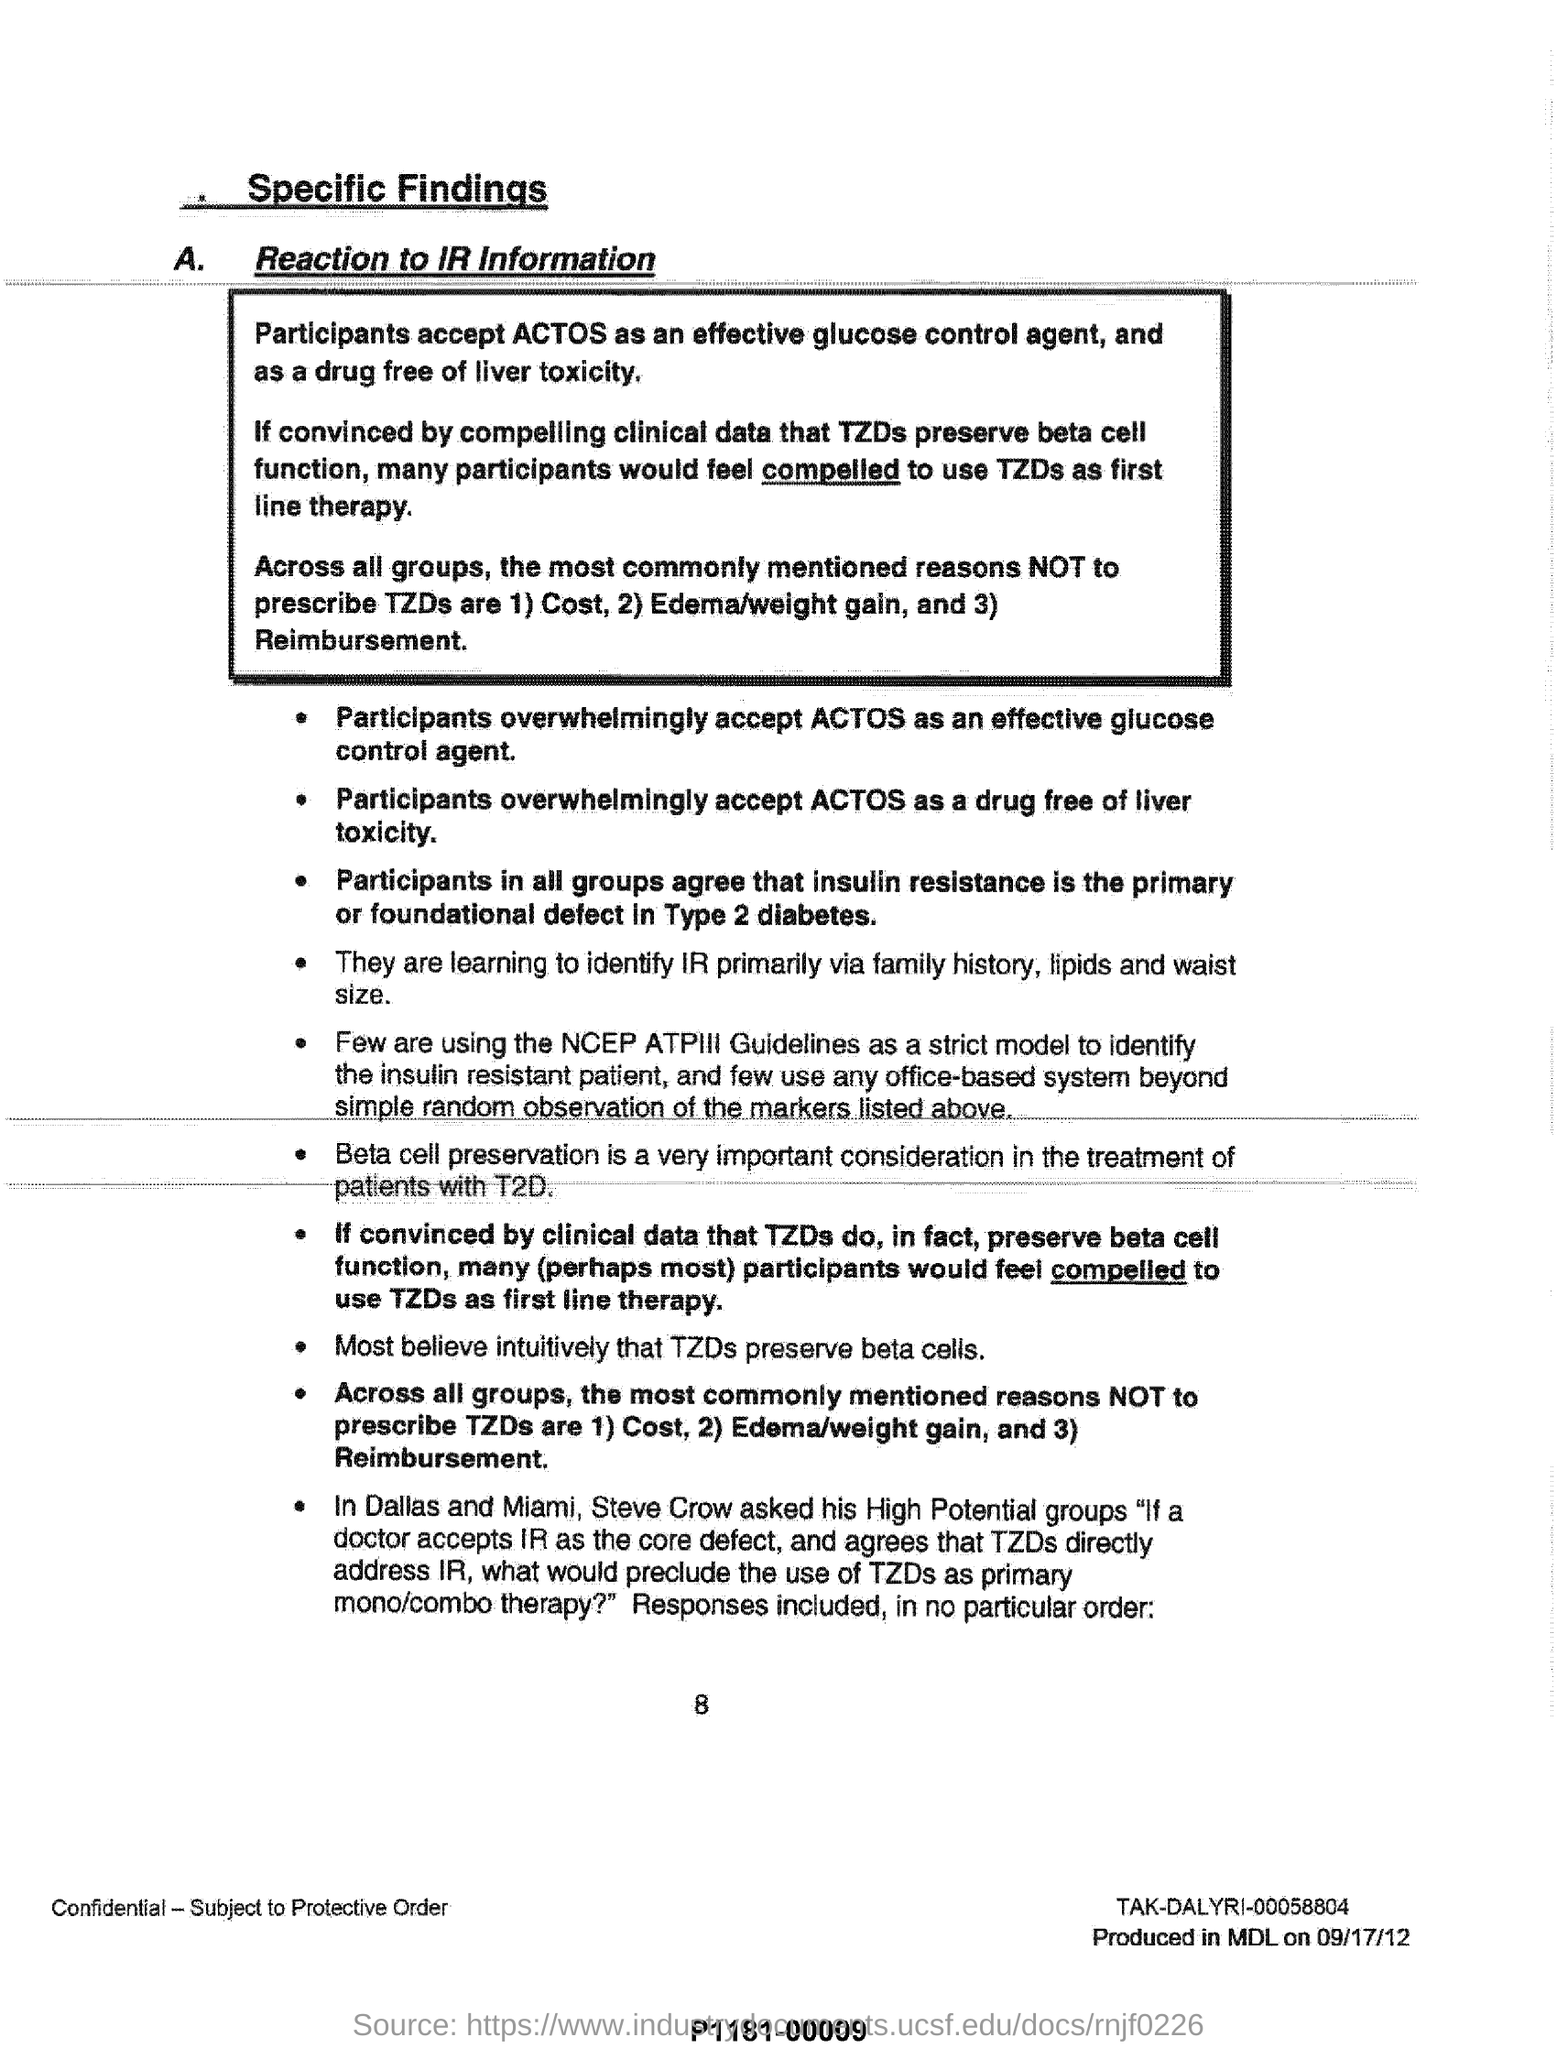Draw attention to some important aspects in this diagram. The reasons not to prescribe thiazide diuretics (TZDs) include cost, the potential for edema and weight gain, and reimbursement issues. What is considered an effective glucose control agent? It is ACTOS. 